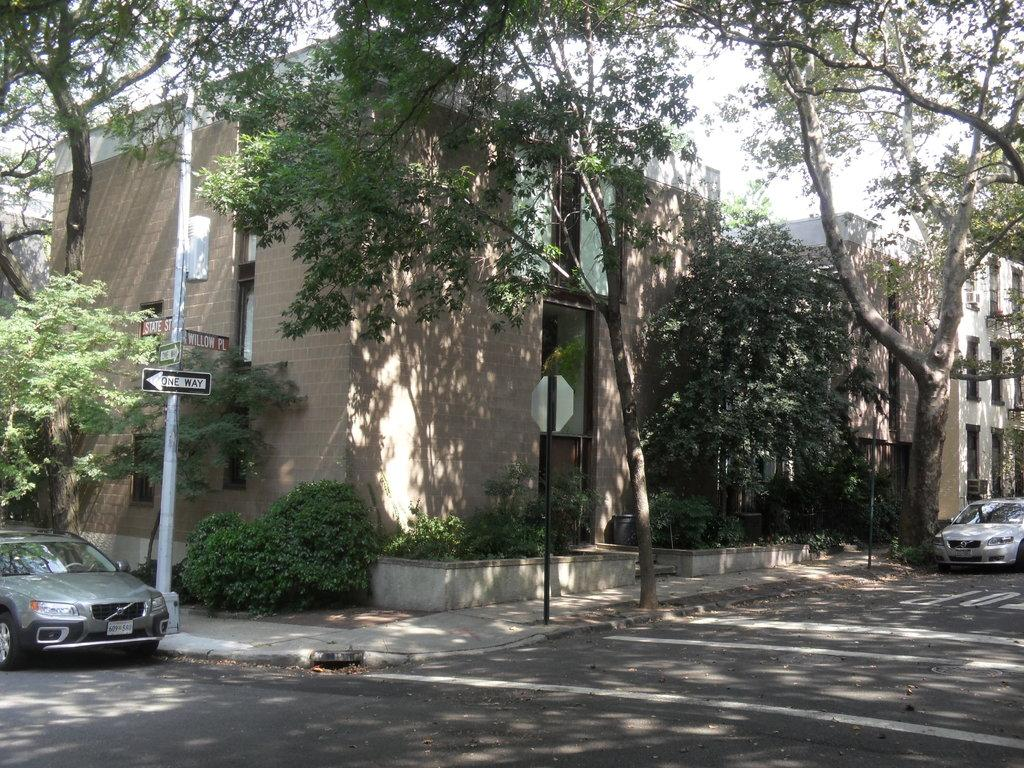What type of structures can be seen in the image? There are buildings in the image. What else can be seen on the ground in the image? There are vehicles and a road in the image. What are the poles used for in the image? The poles are likely used for supporting wires or signs, as they are often found alongside roads and in urban areas. What might be used for providing directions or information in the image? There are instruction boards in the image for providing directions or information. What type of vegetation can be seen in the image? There are plants and trees in the image. What is visible in the sky in the image? The sky is visible in the image. Can you tell me where the joke is located in the image? There is no joke present in the image. What type of vein can be seen running through the trees in the image? There are no veins visible in the image, as veins are a biological feature found in living organisms and not in trees or other inanimate objects. 